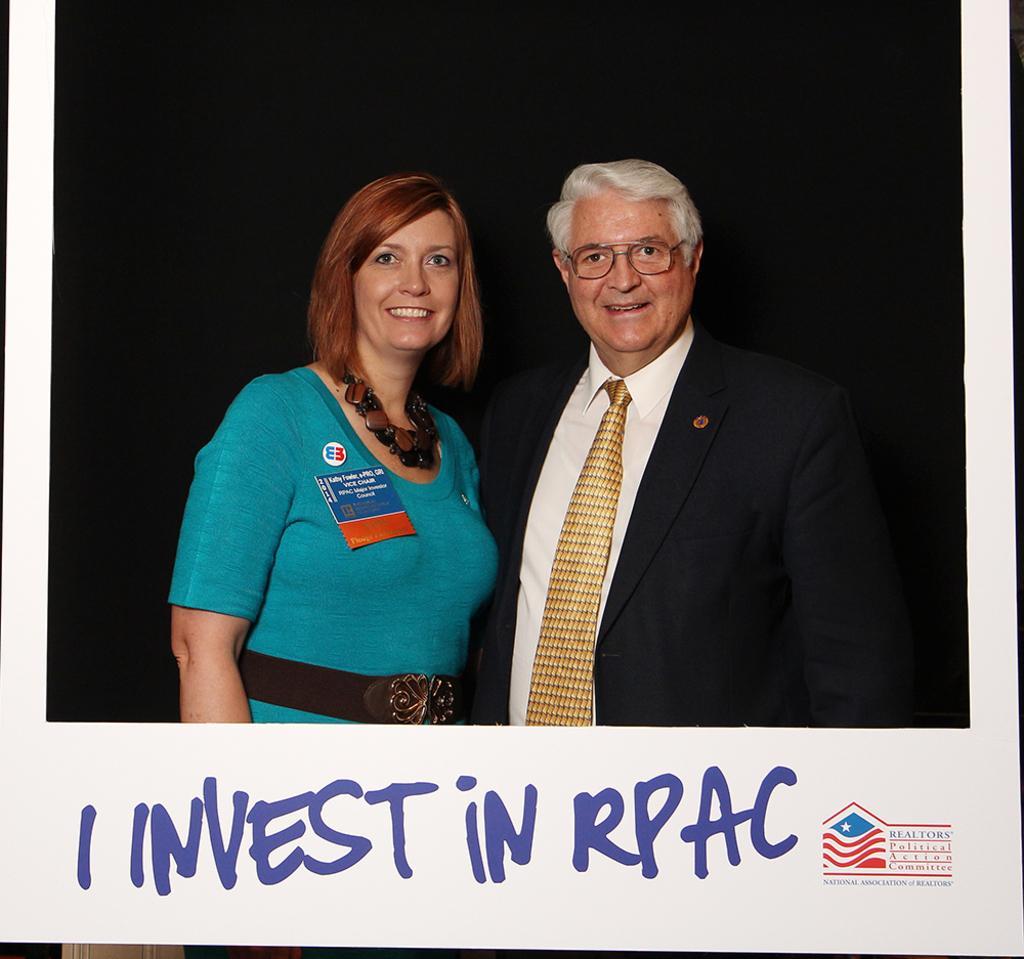Could you give a brief overview of what you see in this image? In this picture there is a old man wearing black color coat standing and giving a pose. Beside there is a another woman wearing green color dress, smiling and giving a pose into the camera. Behind there is a black background. On the bottom side of the image there is a small quote written on it with a water mark. 